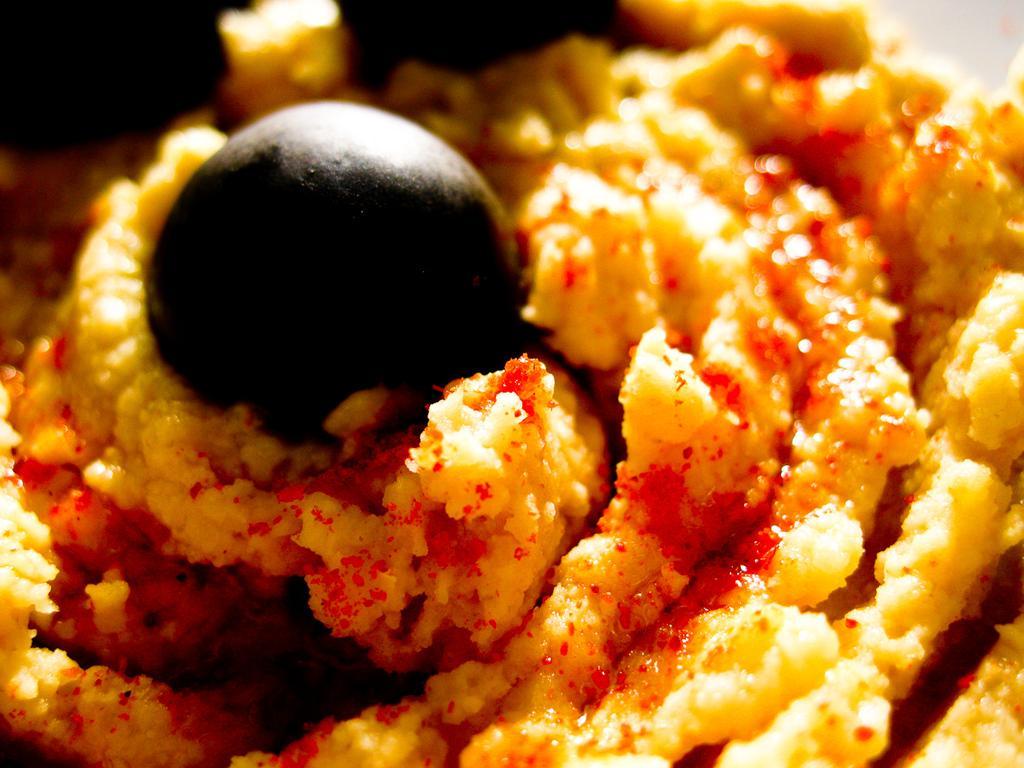Can you describe this image briefly? In this picture we can see some food item and on the food there are some ingredients. 